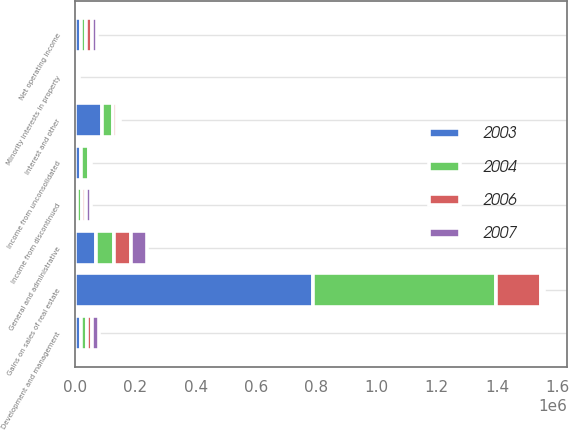Convert chart to OTSL. <chart><loc_0><loc_0><loc_500><loc_500><stacked_bar_chart><ecel><fcel>Net operating income<fcel>Development and management<fcel>Interest and other<fcel>Minority interests in property<fcel>Income from unconsolidated<fcel>Gains on sales of real estate<fcel>Income from discontinued<fcel>General and administrative<nl><fcel>2003<fcel>18565<fcel>20553<fcel>89706<fcel>84<fcel>20428<fcel>789238<fcel>6206<fcel>69882<nl><fcel>2004<fcel>18565<fcel>19820<fcel>36677<fcel>2013<fcel>24507<fcel>606394<fcel>16104<fcel>59375<nl><fcel>2006<fcel>18565<fcel>17310<fcel>11978<fcel>6017<fcel>4829<fcel>151884<fcel>15327<fcel>55471<nl><fcel>2007<fcel>18565<fcel>20440<fcel>10334<fcel>4685<fcel>3380<fcel>8149<fcel>16292<fcel>53636<nl></chart> 